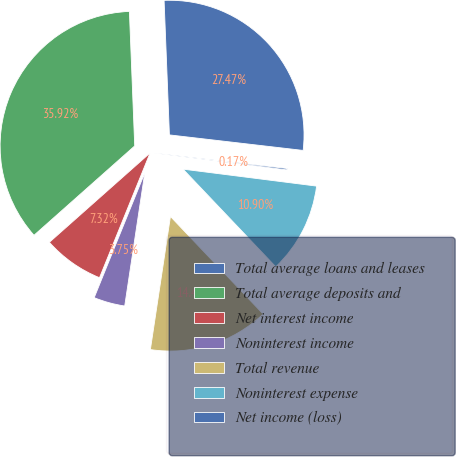<chart> <loc_0><loc_0><loc_500><loc_500><pie_chart><fcel>Total average loans and leases<fcel>Total average deposits and<fcel>Net interest income<fcel>Noninterest income<fcel>Total revenue<fcel>Noninterest expense<fcel>Net income (loss)<nl><fcel>27.47%<fcel>35.92%<fcel>7.32%<fcel>3.75%<fcel>14.47%<fcel>10.9%<fcel>0.17%<nl></chart> 